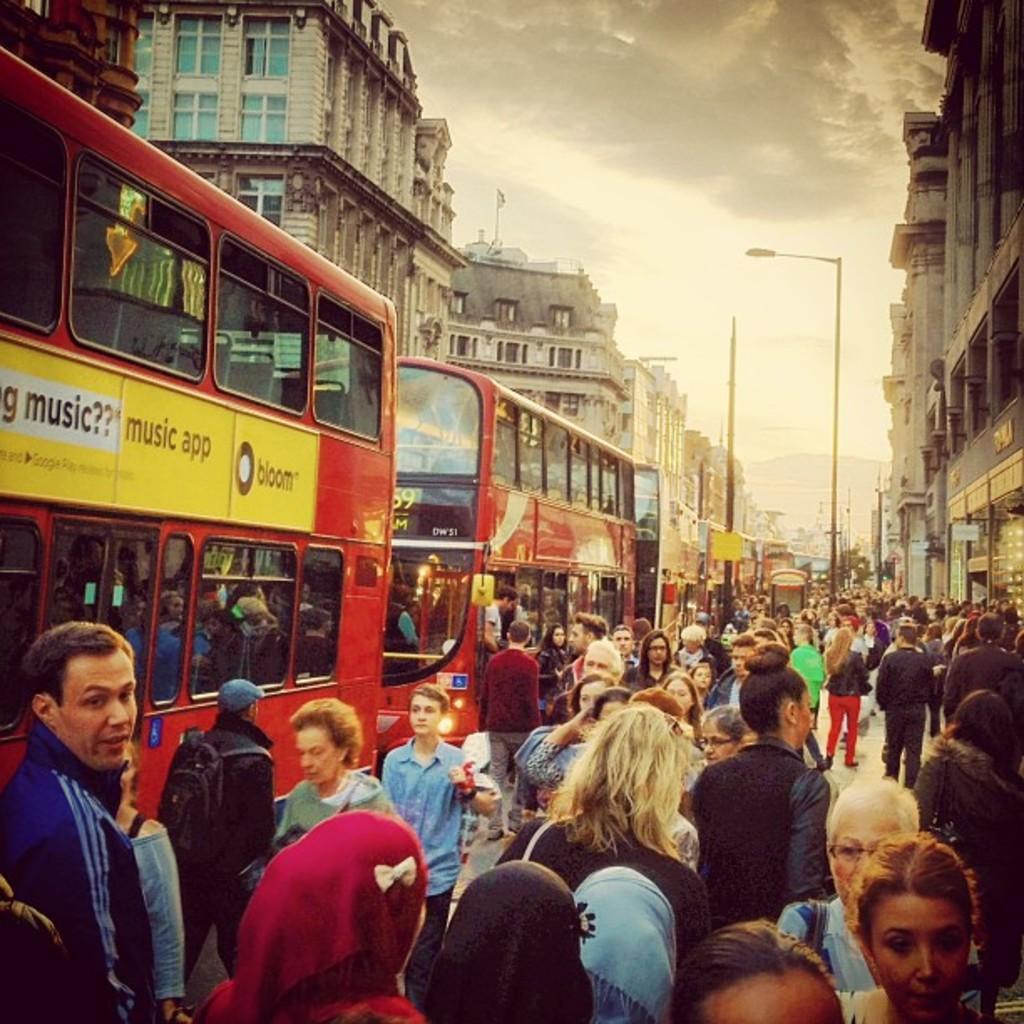Could you give a brief overview of what you see in this image? In this image there are crowd´s of people, there are buses, there is a street light, there are poles, there are buildingś, there is a sky. 